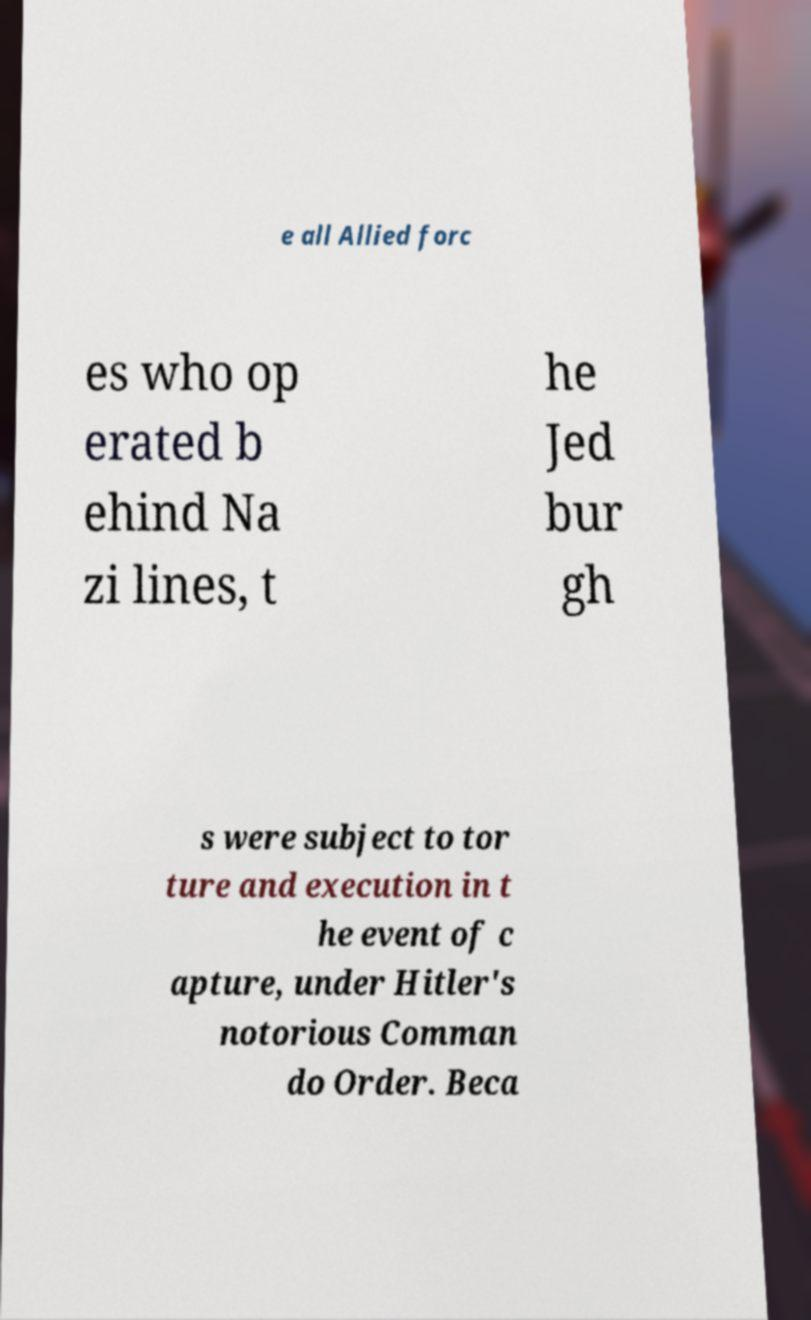Please read and relay the text visible in this image. What does it say? e all Allied forc es who op erated b ehind Na zi lines, t he Jed bur gh s were subject to tor ture and execution in t he event of c apture, under Hitler's notorious Comman do Order. Beca 